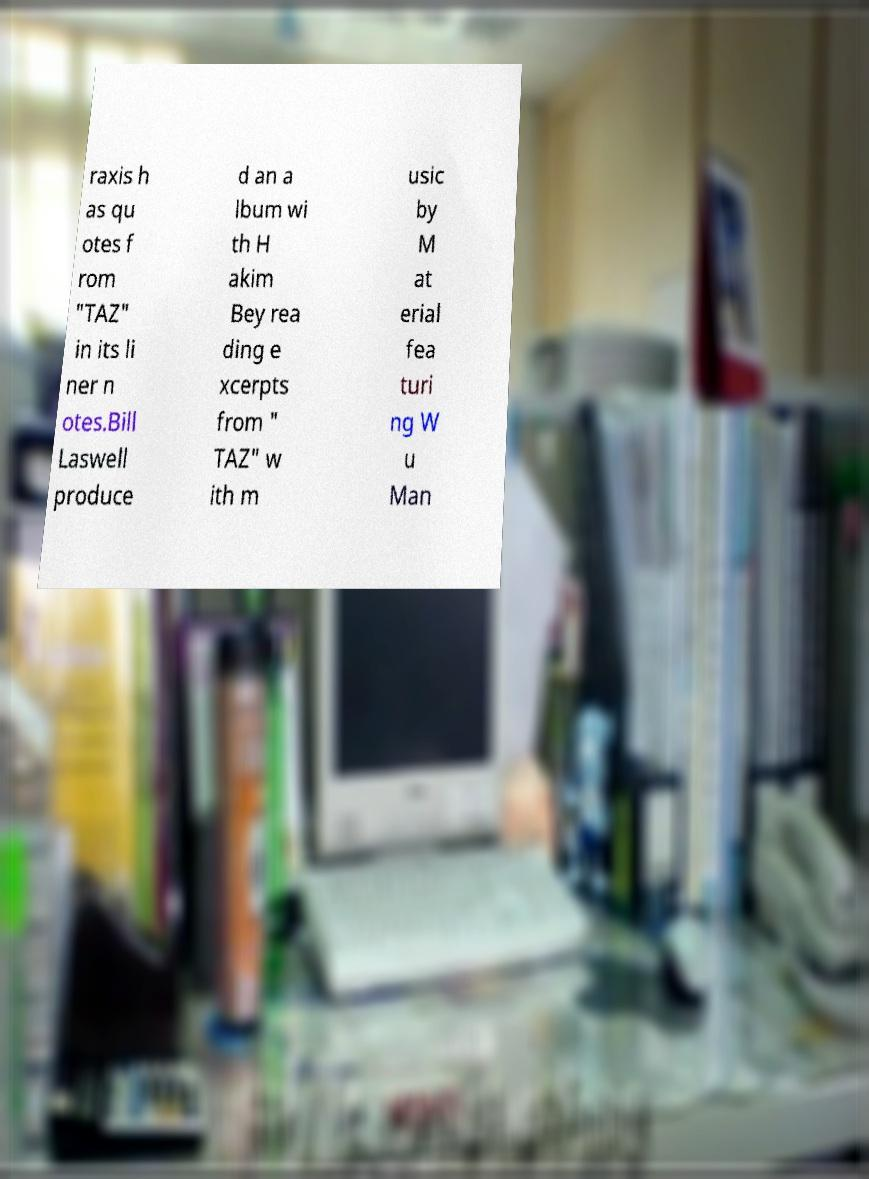For documentation purposes, I need the text within this image transcribed. Could you provide that? raxis h as qu otes f rom "TAZ" in its li ner n otes.Bill Laswell produce d an a lbum wi th H akim Bey rea ding e xcerpts from " TAZ" w ith m usic by M at erial fea turi ng W u Man 